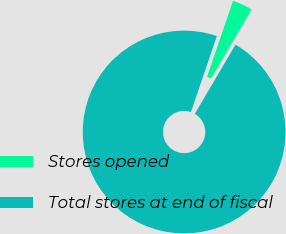<chart> <loc_0><loc_0><loc_500><loc_500><pie_chart><fcel>Stores opened<fcel>Total stores at end of fiscal<nl><fcel>3.23%<fcel>96.77%<nl></chart> 